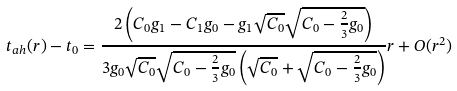Convert formula to latex. <formula><loc_0><loc_0><loc_500><loc_500>t _ { a h } ( r ) - t _ { 0 } = \frac { 2 \left ( C _ { 0 } g _ { 1 } - C _ { 1 } g _ { 0 } - g _ { 1 } \sqrt { C _ { 0 } } \sqrt { C _ { 0 } - \frac { 2 } { 3 } g _ { 0 } } \right ) } { 3 g _ { 0 } \sqrt { C _ { 0 } } \sqrt { C _ { 0 } - \frac { 2 } { 3 } g _ { 0 } } \left ( \sqrt { C _ { 0 } } + \sqrt { C _ { 0 } - \frac { 2 } { 3 } g _ { 0 } } \right ) } r + O ( r ^ { 2 } )</formula> 